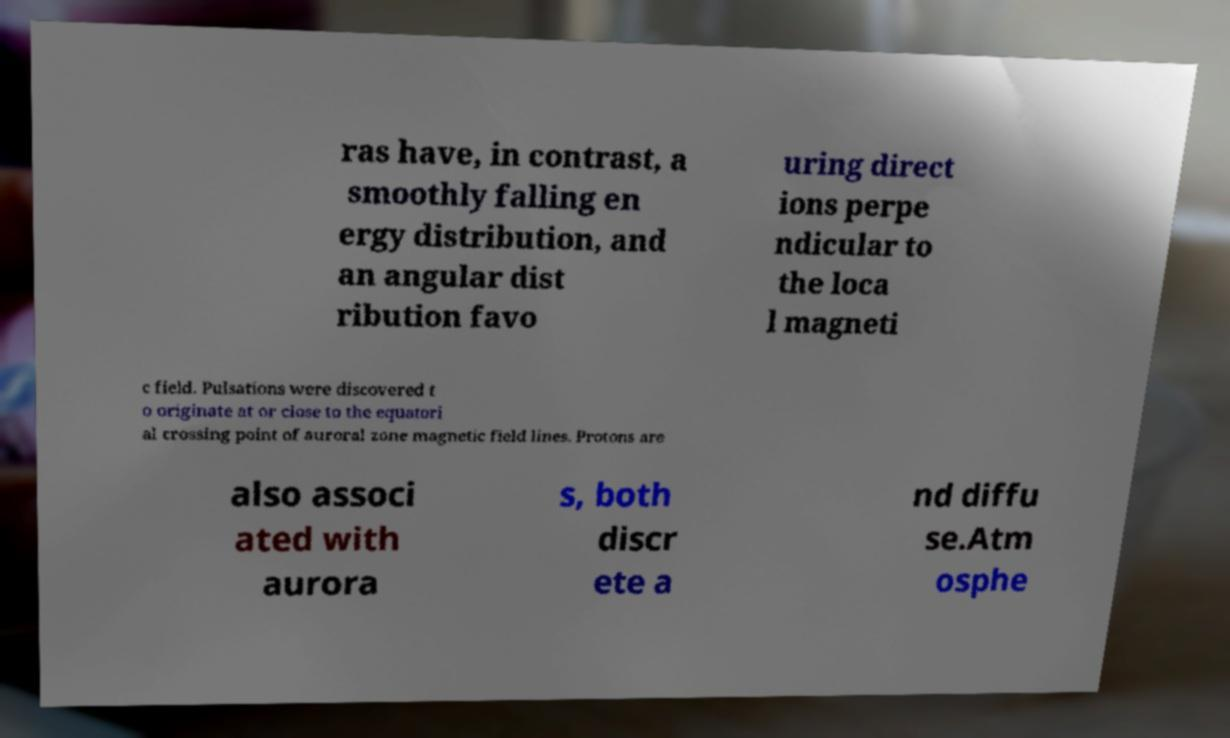Can you accurately transcribe the text from the provided image for me? ras have, in contrast, a smoothly falling en ergy distribution, and an angular dist ribution favo uring direct ions perpe ndicular to the loca l magneti c field. Pulsations were discovered t o originate at or close to the equatori al crossing point of auroral zone magnetic field lines. Protons are also associ ated with aurora s, both discr ete a nd diffu se.Atm osphe 